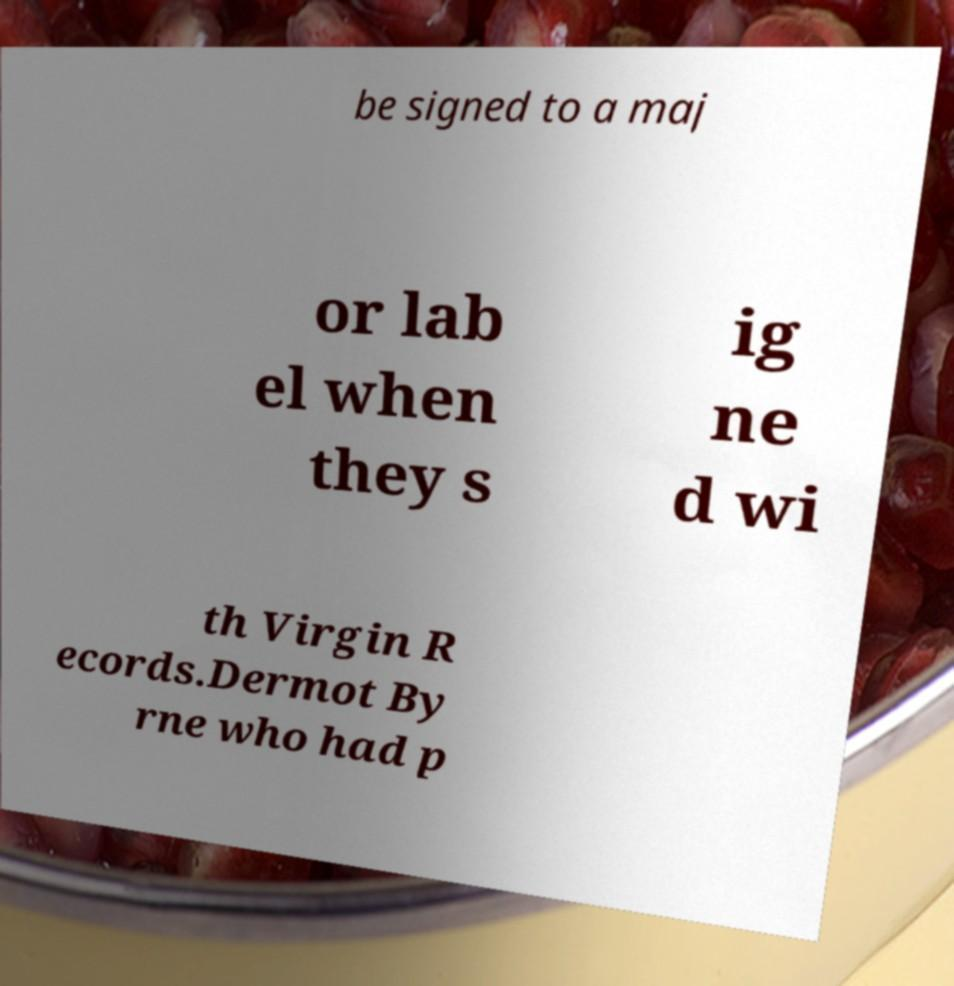What messages or text are displayed in this image? I need them in a readable, typed format. be signed to a maj or lab el when they s ig ne d wi th Virgin R ecords.Dermot By rne who had p 